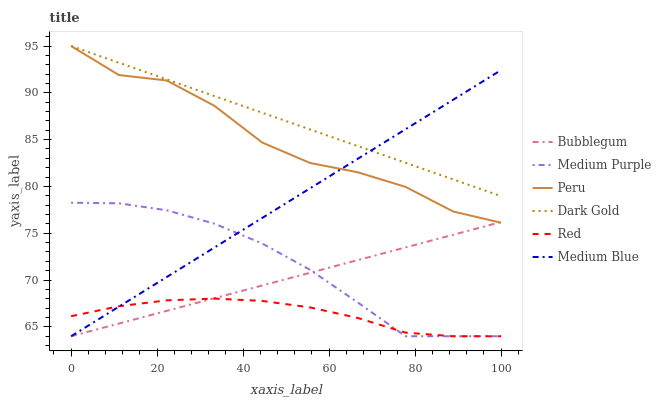Does Red have the minimum area under the curve?
Answer yes or no. Yes. Does Dark Gold have the maximum area under the curve?
Answer yes or no. Yes. Does Medium Blue have the minimum area under the curve?
Answer yes or no. No. Does Medium Blue have the maximum area under the curve?
Answer yes or no. No. Is Medium Blue the smoothest?
Answer yes or no. Yes. Is Peru the roughest?
Answer yes or no. Yes. Is Bubblegum the smoothest?
Answer yes or no. No. Is Bubblegum the roughest?
Answer yes or no. No. Does Peru have the lowest value?
Answer yes or no. No. Does Peru have the highest value?
Answer yes or no. Yes. Does Medium Blue have the highest value?
Answer yes or no. No. Is Red less than Dark Gold?
Answer yes or no. Yes. Is Dark Gold greater than Medium Purple?
Answer yes or no. Yes. Does Medium Blue intersect Medium Purple?
Answer yes or no. Yes. Is Medium Blue less than Medium Purple?
Answer yes or no. No. Is Medium Blue greater than Medium Purple?
Answer yes or no. No. Does Red intersect Dark Gold?
Answer yes or no. No. 